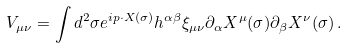Convert formula to latex. <formula><loc_0><loc_0><loc_500><loc_500>V _ { \mu \nu } = \int d ^ { 2 } \sigma e ^ { i p \cdot X ( \sigma ) } h ^ { \alpha \beta } \xi _ { \mu \nu } \partial _ { \alpha } X ^ { \mu } ( \sigma ) \partial _ { \beta } X ^ { \nu } ( \sigma ) \, .</formula> 